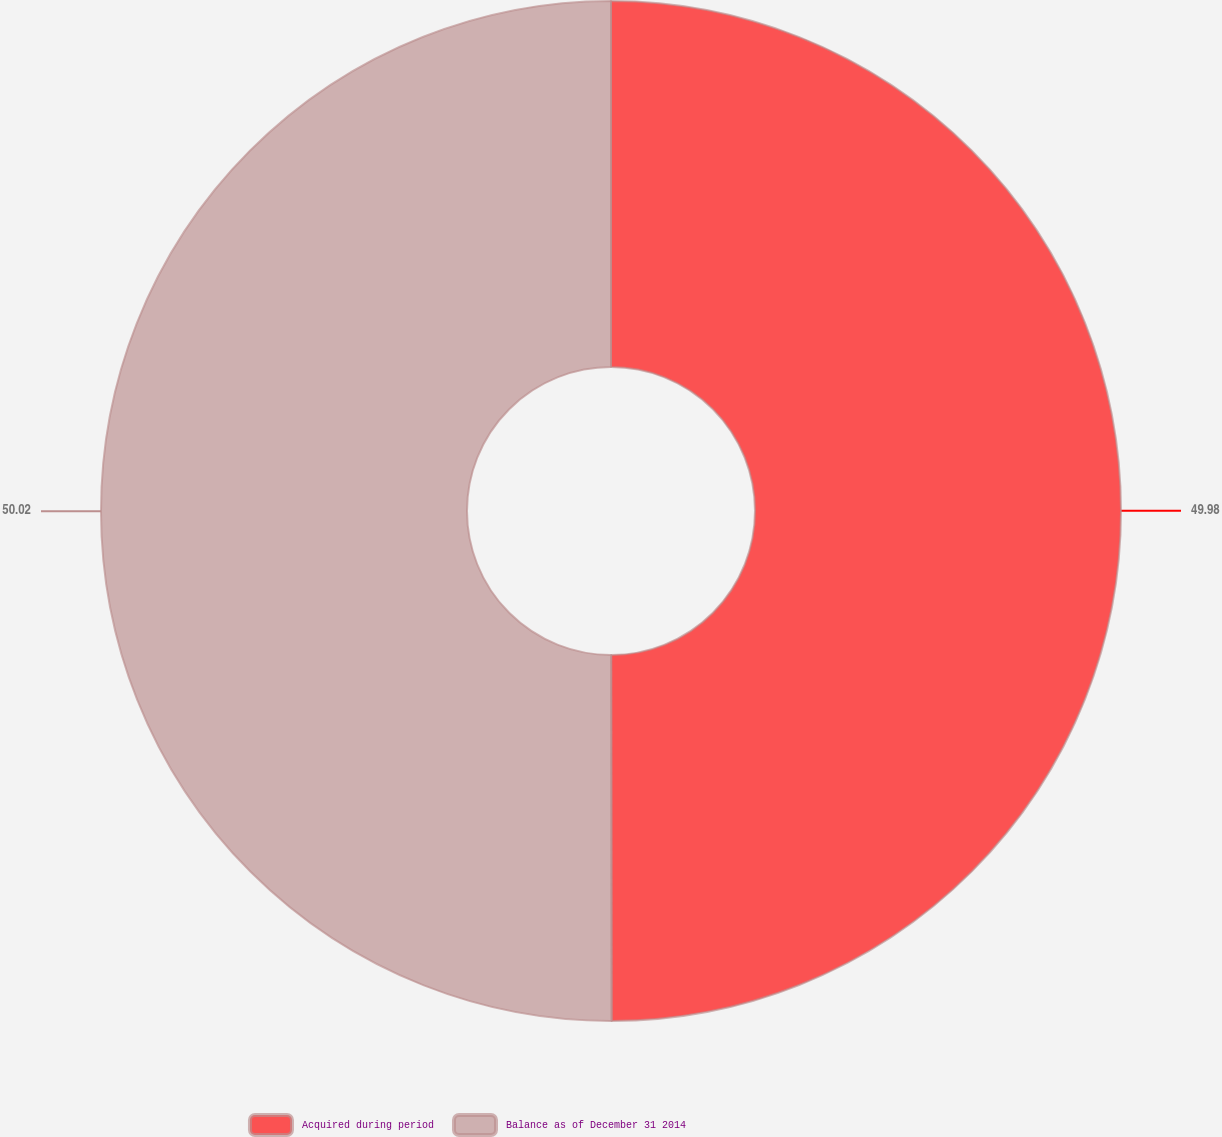Convert chart. <chart><loc_0><loc_0><loc_500><loc_500><pie_chart><fcel>Acquired during period<fcel>Balance as of December 31 2014<nl><fcel>49.98%<fcel>50.02%<nl></chart> 